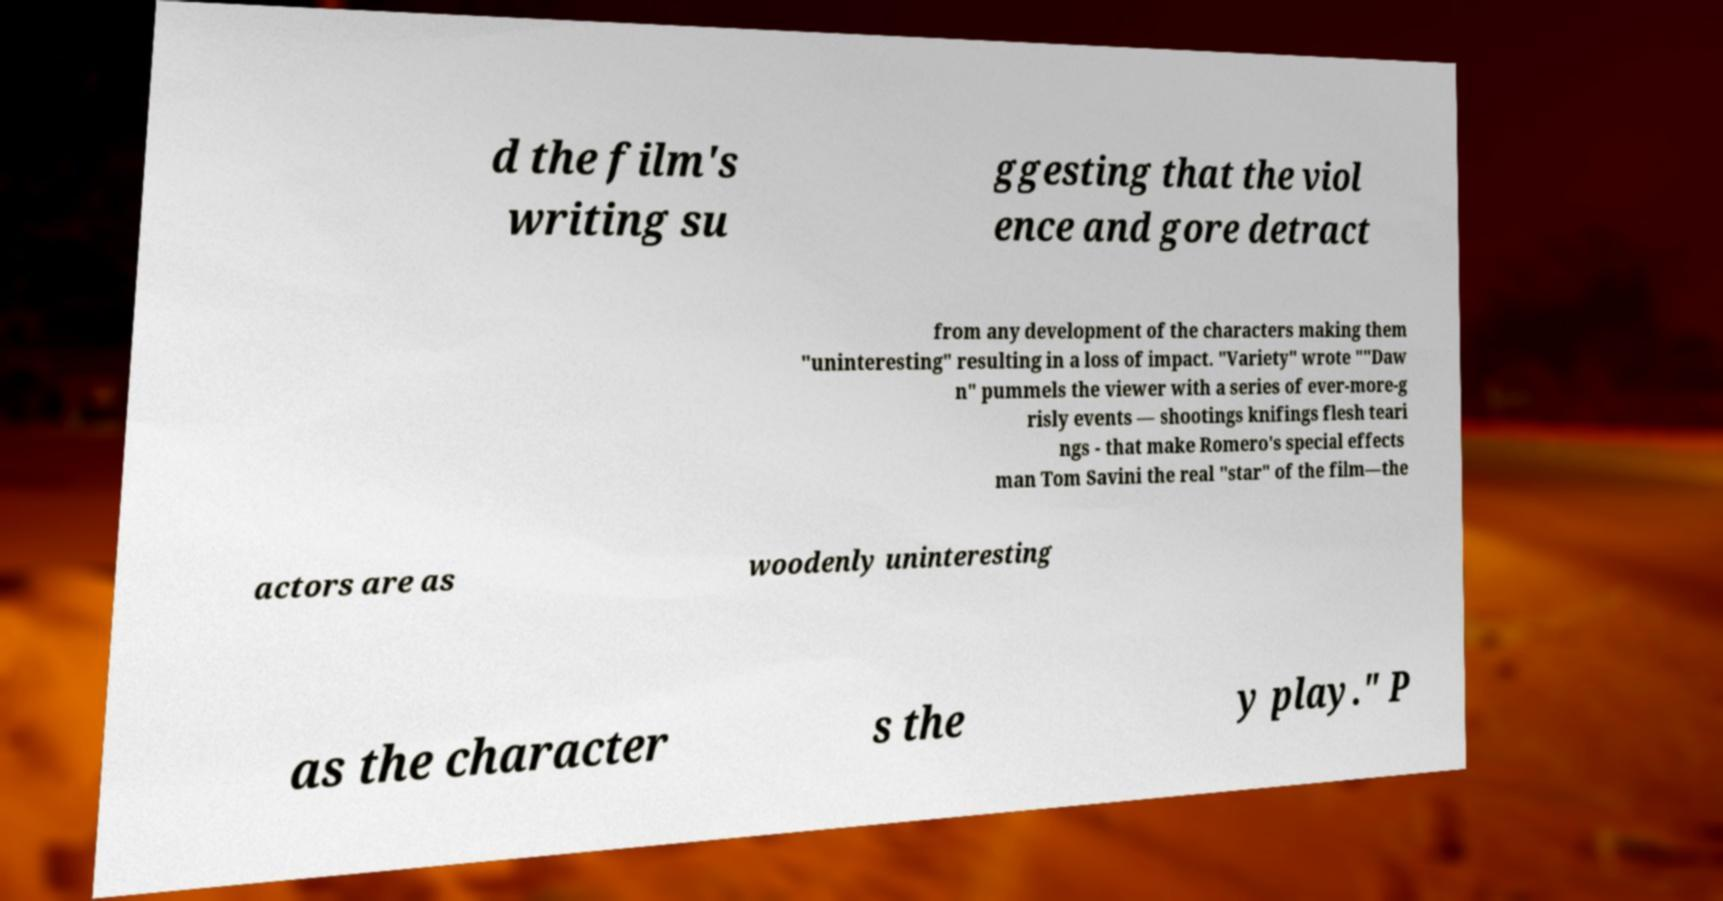Can you accurately transcribe the text from the provided image for me? d the film's writing su ggesting that the viol ence and gore detract from any development of the characters making them "uninteresting" resulting in a loss of impact. "Variety" wrote ""Daw n" pummels the viewer with a series of ever-more-g risly events — shootings knifings flesh teari ngs - that make Romero's special effects man Tom Savini the real "star" of the film—the actors are as woodenly uninteresting as the character s the y play." P 